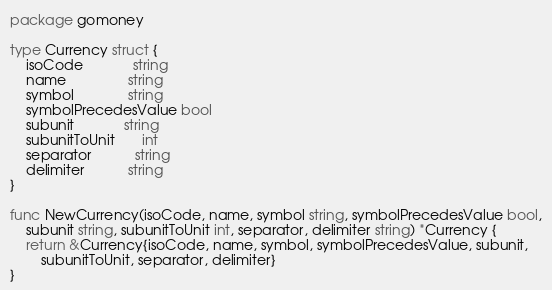Convert code to text. <code><loc_0><loc_0><loc_500><loc_500><_Go_>package gomoney

type Currency struct {
	isoCode             string
	name                string
	symbol              string
	symbolPrecedesValue bool
	subunit             string
	subunitToUnit       int
	separator           string
	delimiter           string
}

func NewCurrency(isoCode, name, symbol string, symbolPrecedesValue bool,
	subunit string, subunitToUnit int, separator, delimiter string) *Currency {
	return &Currency{isoCode, name, symbol, symbolPrecedesValue, subunit,
		subunitToUnit, separator, delimiter}
}
</code> 